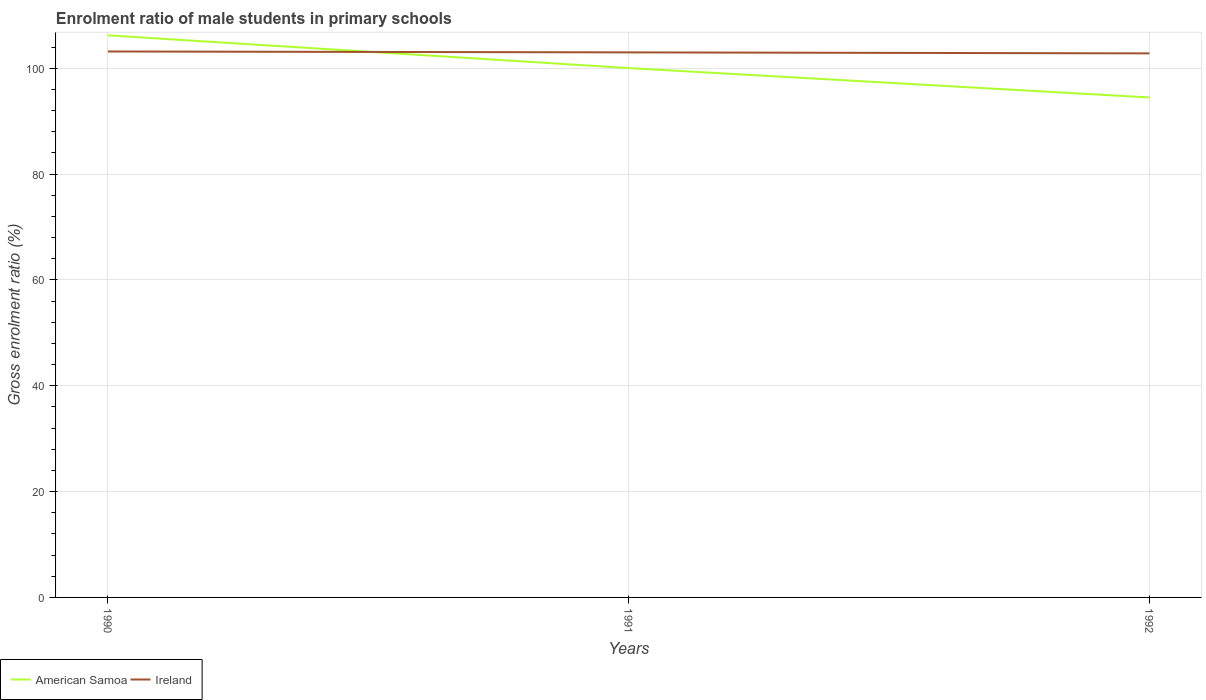How many different coloured lines are there?
Keep it short and to the point. 2. Is the number of lines equal to the number of legend labels?
Ensure brevity in your answer.  Yes. Across all years, what is the maximum enrolment ratio of male students in primary schools in American Samoa?
Provide a short and direct response. 94.47. What is the total enrolment ratio of male students in primary schools in American Samoa in the graph?
Offer a terse response. 5.56. What is the difference between the highest and the second highest enrolment ratio of male students in primary schools in American Samoa?
Your answer should be compact. 11.74. How many lines are there?
Give a very brief answer. 2. How many years are there in the graph?
Ensure brevity in your answer.  3. Does the graph contain grids?
Provide a short and direct response. Yes. How many legend labels are there?
Your response must be concise. 2. What is the title of the graph?
Keep it short and to the point. Enrolment ratio of male students in primary schools. What is the Gross enrolment ratio (%) in American Samoa in 1990?
Offer a terse response. 106.21. What is the Gross enrolment ratio (%) in Ireland in 1990?
Your response must be concise. 103.16. What is the Gross enrolment ratio (%) in American Samoa in 1991?
Give a very brief answer. 100.02. What is the Gross enrolment ratio (%) in Ireland in 1991?
Your response must be concise. 102.99. What is the Gross enrolment ratio (%) of American Samoa in 1992?
Provide a succinct answer. 94.47. What is the Gross enrolment ratio (%) in Ireland in 1992?
Your answer should be very brief. 102.8. Across all years, what is the maximum Gross enrolment ratio (%) in American Samoa?
Your answer should be compact. 106.21. Across all years, what is the maximum Gross enrolment ratio (%) of Ireland?
Ensure brevity in your answer.  103.16. Across all years, what is the minimum Gross enrolment ratio (%) of American Samoa?
Your response must be concise. 94.47. Across all years, what is the minimum Gross enrolment ratio (%) in Ireland?
Offer a very short reply. 102.8. What is the total Gross enrolment ratio (%) in American Samoa in the graph?
Provide a short and direct response. 300.7. What is the total Gross enrolment ratio (%) of Ireland in the graph?
Offer a terse response. 308.95. What is the difference between the Gross enrolment ratio (%) of American Samoa in 1990 and that in 1991?
Your answer should be compact. 6.18. What is the difference between the Gross enrolment ratio (%) of Ireland in 1990 and that in 1991?
Provide a succinct answer. 0.17. What is the difference between the Gross enrolment ratio (%) in American Samoa in 1990 and that in 1992?
Ensure brevity in your answer.  11.74. What is the difference between the Gross enrolment ratio (%) of Ireland in 1990 and that in 1992?
Ensure brevity in your answer.  0.36. What is the difference between the Gross enrolment ratio (%) in American Samoa in 1991 and that in 1992?
Offer a terse response. 5.56. What is the difference between the Gross enrolment ratio (%) of Ireland in 1991 and that in 1992?
Ensure brevity in your answer.  0.19. What is the difference between the Gross enrolment ratio (%) of American Samoa in 1990 and the Gross enrolment ratio (%) of Ireland in 1991?
Provide a short and direct response. 3.22. What is the difference between the Gross enrolment ratio (%) of American Samoa in 1990 and the Gross enrolment ratio (%) of Ireland in 1992?
Your response must be concise. 3.4. What is the difference between the Gross enrolment ratio (%) in American Samoa in 1991 and the Gross enrolment ratio (%) in Ireland in 1992?
Provide a short and direct response. -2.78. What is the average Gross enrolment ratio (%) of American Samoa per year?
Your answer should be compact. 100.23. What is the average Gross enrolment ratio (%) in Ireland per year?
Keep it short and to the point. 102.98. In the year 1990, what is the difference between the Gross enrolment ratio (%) of American Samoa and Gross enrolment ratio (%) of Ireland?
Your answer should be compact. 3.05. In the year 1991, what is the difference between the Gross enrolment ratio (%) in American Samoa and Gross enrolment ratio (%) in Ireland?
Provide a succinct answer. -2.97. In the year 1992, what is the difference between the Gross enrolment ratio (%) of American Samoa and Gross enrolment ratio (%) of Ireland?
Make the answer very short. -8.33. What is the ratio of the Gross enrolment ratio (%) of American Samoa in 1990 to that in 1991?
Keep it short and to the point. 1.06. What is the ratio of the Gross enrolment ratio (%) of Ireland in 1990 to that in 1991?
Provide a succinct answer. 1. What is the ratio of the Gross enrolment ratio (%) in American Samoa in 1990 to that in 1992?
Provide a short and direct response. 1.12. What is the ratio of the Gross enrolment ratio (%) in Ireland in 1990 to that in 1992?
Provide a short and direct response. 1. What is the ratio of the Gross enrolment ratio (%) of American Samoa in 1991 to that in 1992?
Ensure brevity in your answer.  1.06. What is the difference between the highest and the second highest Gross enrolment ratio (%) in American Samoa?
Offer a very short reply. 6.18. What is the difference between the highest and the second highest Gross enrolment ratio (%) in Ireland?
Provide a short and direct response. 0.17. What is the difference between the highest and the lowest Gross enrolment ratio (%) of American Samoa?
Give a very brief answer. 11.74. What is the difference between the highest and the lowest Gross enrolment ratio (%) of Ireland?
Offer a very short reply. 0.36. 